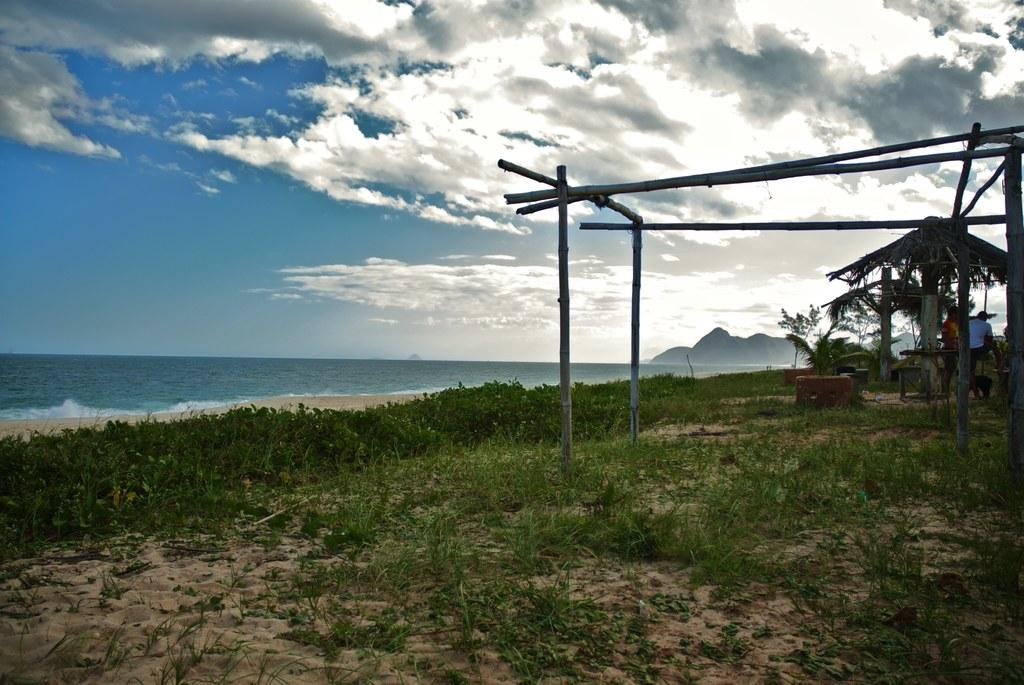What is at the bottom of the image? There is sand at the bottom of the image. What is growing in the sand? There are plants in the sand. What can be seen in the background of the image? There are trees, wooden poles, a beach, mountains, and the sky visible in the background of the image. What type of liquid is being served at the feast in the image? There is no feast present in the image, so it is not possible to determine what type of liquid might be served. 